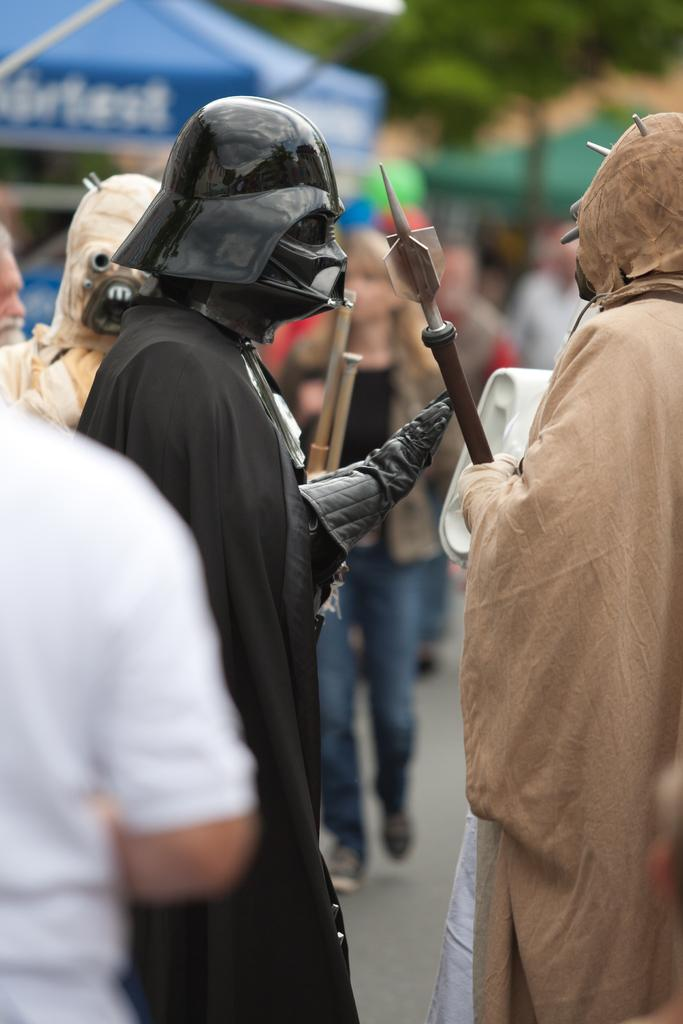What are the people in the image wearing? The people in the image are wearing costumes. What can be seen beneath the people's feet in the image? The ground is visible in the image. What type of vegetation is present in the image? There are trees in the image. What type of temporary shelter can be seen in the image? There are tents in the image. What type of care system is being used to maintain the trees in the image? There is no indication of a care system for the trees in the image; they appear to be natural vegetation. 